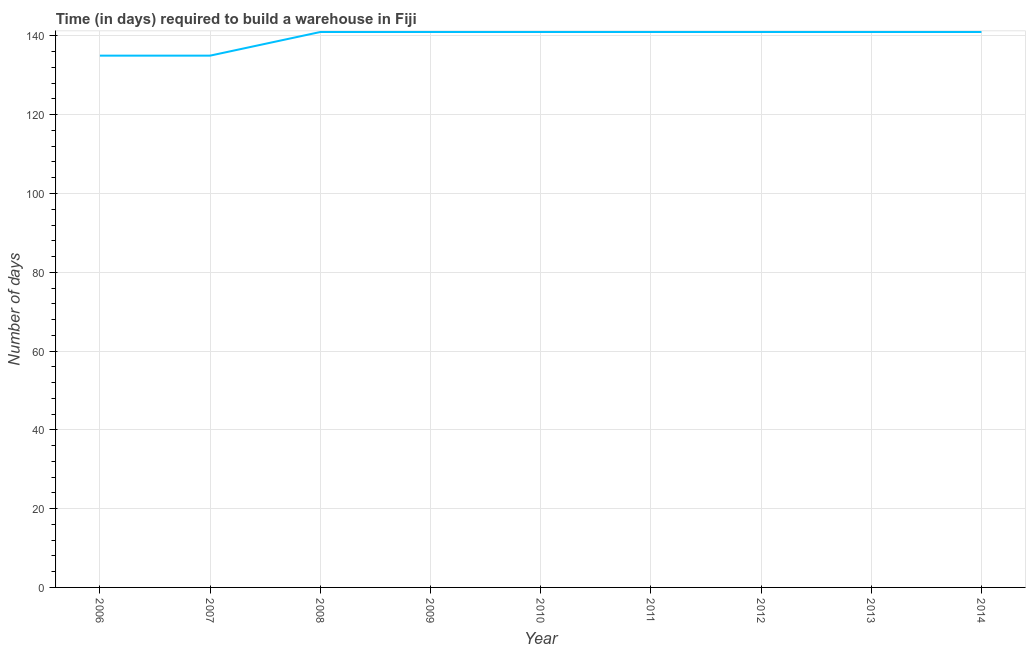What is the time required to build a warehouse in 2007?
Your response must be concise. 135. Across all years, what is the maximum time required to build a warehouse?
Make the answer very short. 141. Across all years, what is the minimum time required to build a warehouse?
Provide a succinct answer. 135. In which year was the time required to build a warehouse maximum?
Give a very brief answer. 2008. In which year was the time required to build a warehouse minimum?
Your response must be concise. 2006. What is the sum of the time required to build a warehouse?
Make the answer very short. 1257. What is the average time required to build a warehouse per year?
Your answer should be compact. 139.67. What is the median time required to build a warehouse?
Make the answer very short. 141. What is the ratio of the time required to build a warehouse in 2009 to that in 2011?
Your answer should be very brief. 1. Is the time required to build a warehouse in 2008 less than that in 2009?
Provide a succinct answer. No. Is the difference between the time required to build a warehouse in 2006 and 2013 greater than the difference between any two years?
Provide a succinct answer. Yes. What is the difference between the highest and the second highest time required to build a warehouse?
Keep it short and to the point. 0. Is the sum of the time required to build a warehouse in 2008 and 2014 greater than the maximum time required to build a warehouse across all years?
Keep it short and to the point. Yes. What is the difference between the highest and the lowest time required to build a warehouse?
Give a very brief answer. 6. How many lines are there?
Offer a terse response. 1. How many years are there in the graph?
Your answer should be very brief. 9. What is the title of the graph?
Your response must be concise. Time (in days) required to build a warehouse in Fiji. What is the label or title of the Y-axis?
Your answer should be compact. Number of days. What is the Number of days in 2006?
Keep it short and to the point. 135. What is the Number of days in 2007?
Offer a terse response. 135. What is the Number of days of 2008?
Give a very brief answer. 141. What is the Number of days of 2009?
Ensure brevity in your answer.  141. What is the Number of days in 2010?
Give a very brief answer. 141. What is the Number of days of 2011?
Ensure brevity in your answer.  141. What is the Number of days of 2012?
Provide a succinct answer. 141. What is the Number of days in 2013?
Offer a terse response. 141. What is the Number of days of 2014?
Give a very brief answer. 141. What is the difference between the Number of days in 2006 and 2008?
Your answer should be compact. -6. What is the difference between the Number of days in 2006 and 2009?
Your answer should be compact. -6. What is the difference between the Number of days in 2006 and 2010?
Your response must be concise. -6. What is the difference between the Number of days in 2006 and 2014?
Ensure brevity in your answer.  -6. What is the difference between the Number of days in 2007 and 2009?
Your answer should be very brief. -6. What is the difference between the Number of days in 2007 and 2012?
Give a very brief answer. -6. What is the difference between the Number of days in 2007 and 2014?
Give a very brief answer. -6. What is the difference between the Number of days in 2008 and 2009?
Provide a succinct answer. 0. What is the difference between the Number of days in 2009 and 2010?
Your answer should be compact. 0. What is the difference between the Number of days in 2010 and 2011?
Ensure brevity in your answer.  0. What is the difference between the Number of days in 2010 and 2012?
Your answer should be compact. 0. What is the difference between the Number of days in 2010 and 2014?
Provide a succinct answer. 0. What is the difference between the Number of days in 2011 and 2012?
Your response must be concise. 0. What is the difference between the Number of days in 2012 and 2014?
Offer a very short reply. 0. What is the ratio of the Number of days in 2006 to that in 2008?
Make the answer very short. 0.96. What is the ratio of the Number of days in 2007 to that in 2008?
Your answer should be very brief. 0.96. What is the ratio of the Number of days in 2007 to that in 2009?
Provide a succinct answer. 0.96. What is the ratio of the Number of days in 2007 to that in 2010?
Offer a terse response. 0.96. What is the ratio of the Number of days in 2007 to that in 2011?
Make the answer very short. 0.96. What is the ratio of the Number of days in 2007 to that in 2014?
Ensure brevity in your answer.  0.96. What is the ratio of the Number of days in 2008 to that in 2010?
Make the answer very short. 1. What is the ratio of the Number of days in 2008 to that in 2012?
Ensure brevity in your answer.  1. What is the ratio of the Number of days in 2008 to that in 2014?
Provide a short and direct response. 1. What is the ratio of the Number of days in 2009 to that in 2010?
Provide a short and direct response. 1. What is the ratio of the Number of days in 2009 to that in 2011?
Offer a terse response. 1. What is the ratio of the Number of days in 2010 to that in 2013?
Ensure brevity in your answer.  1. What is the ratio of the Number of days in 2011 to that in 2012?
Offer a very short reply. 1. What is the ratio of the Number of days in 2012 to that in 2014?
Offer a terse response. 1. What is the ratio of the Number of days in 2013 to that in 2014?
Your answer should be compact. 1. 